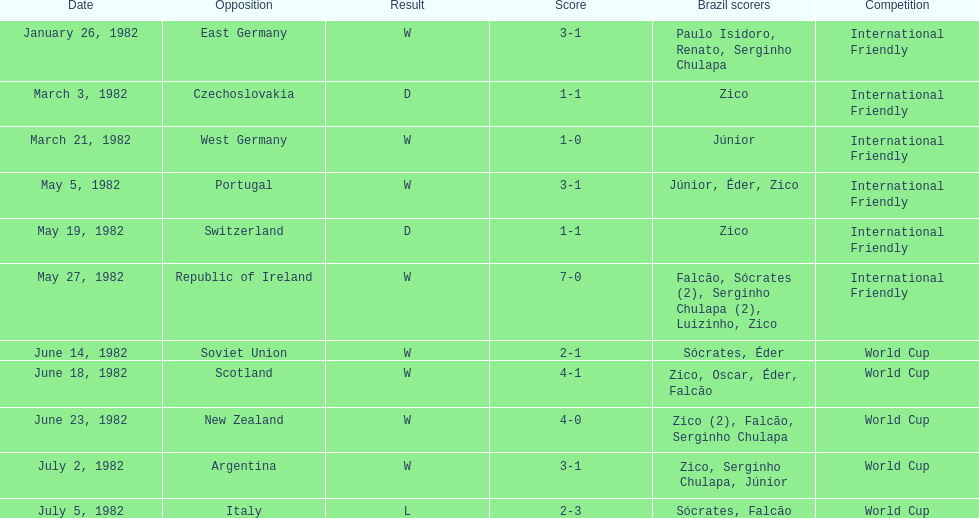What is the earliest date mentioned on the list? January 26, 1982. 